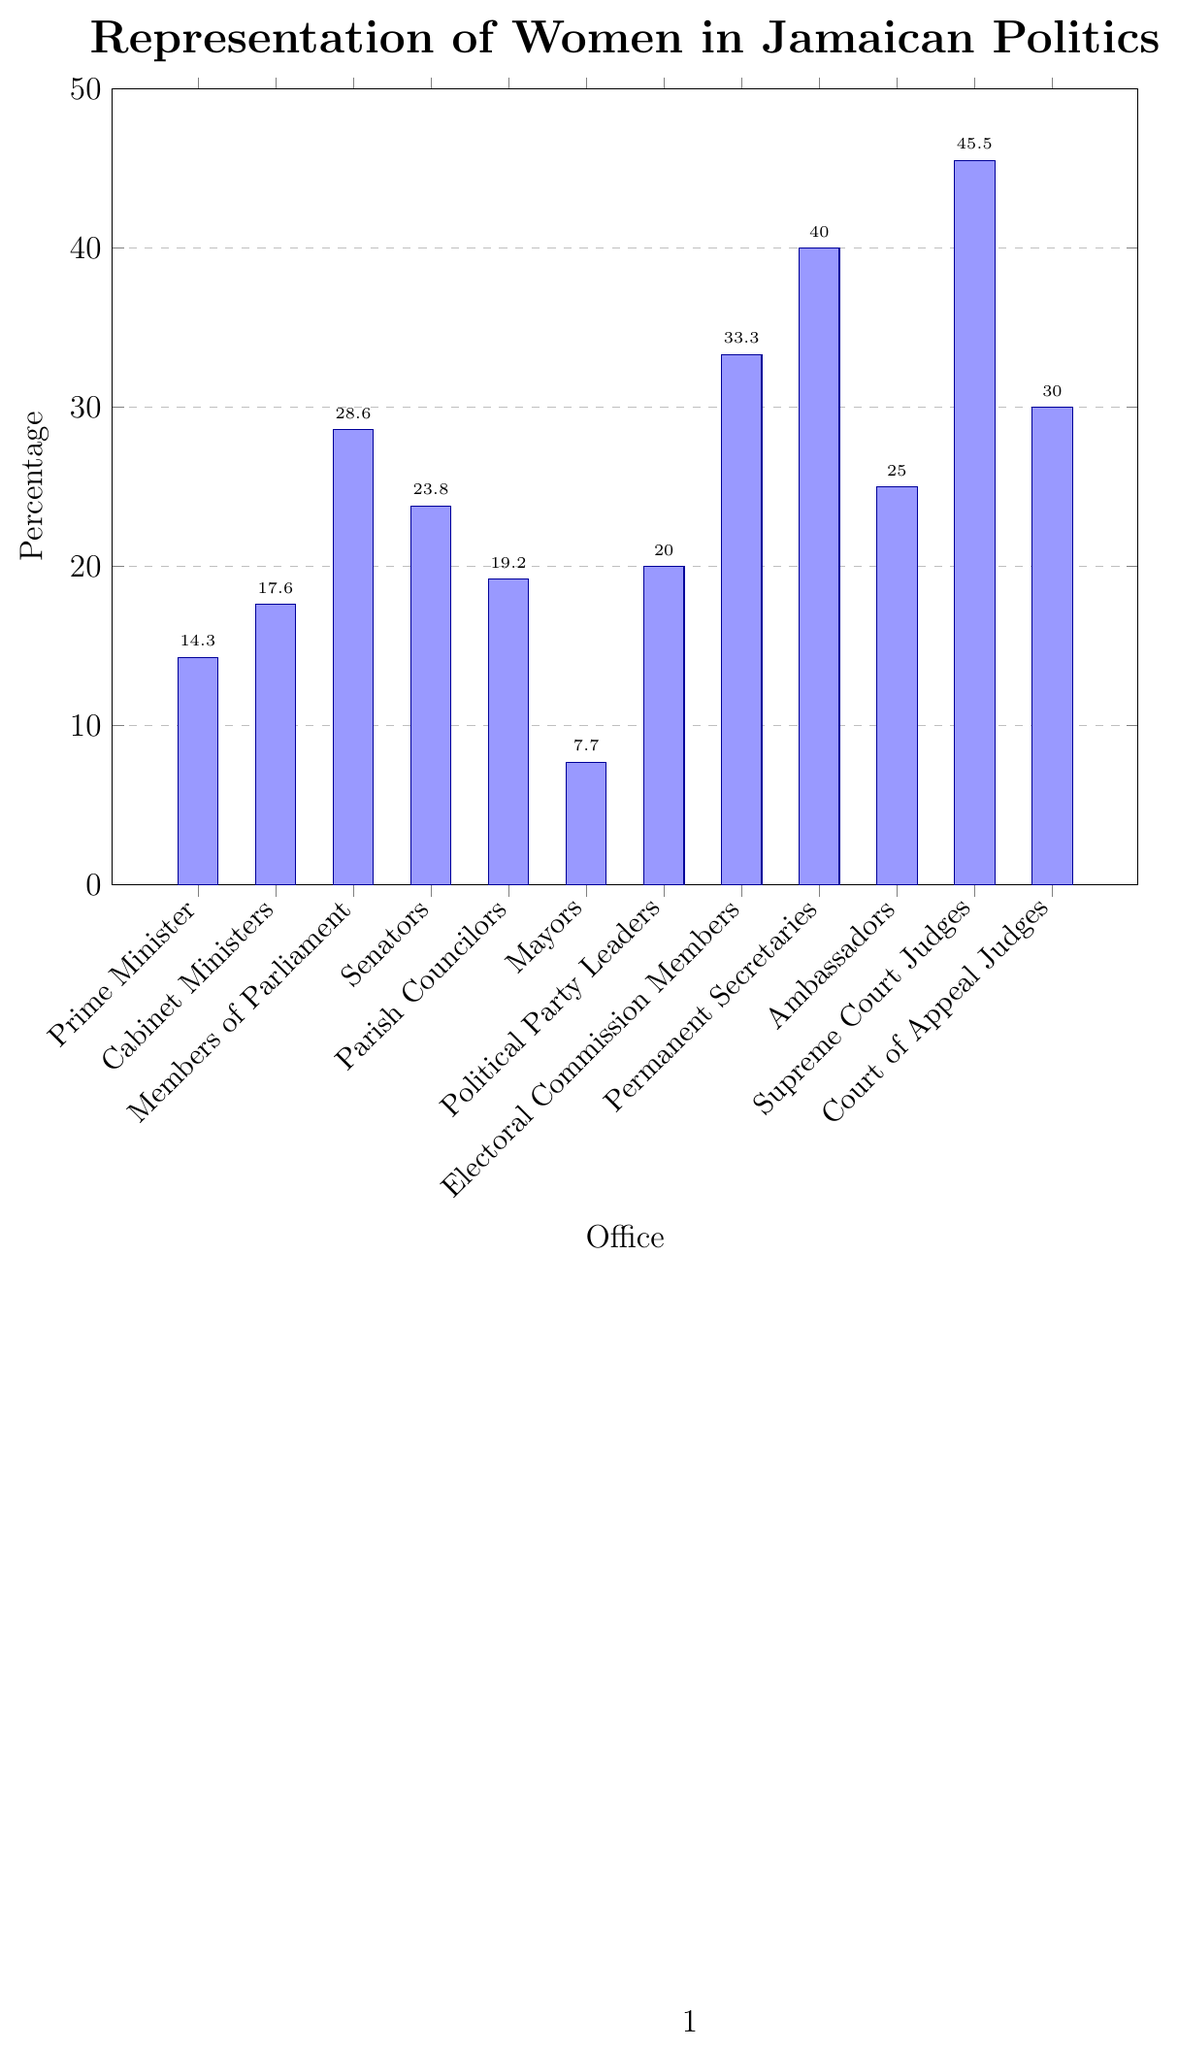What percentage of Supreme Court Judges are women? Look at the bar representing Supreme Court Judges, which is labeled on the x-axis and read the corresponding percentage on the y-axis.
Answer: 45.5 Which political office has the highest representation of women? Among all the bars, the tallest represents the office with the highest percentage.
Answer: Supreme Court Judges Which political office has the lowest representation of women? Identify the shortest bar among all, which indicates the office with the lowest percentage.
Answer: Mayors How does the percentage of women Cabinet Ministers compare to that of women Members of Parliament? Compare the heights of the bars labeled "Cabinet Ministers" and "Members of Parliament" to see which one is taller.
Answer: Members of Parliament have a higher percentage than Cabinet Ministers What is the combined percentage of women in the offices of Prime Minister, Cabinet Ministers, and Mayors? Add the percentages of Prime Minister (14.3), Cabinet Ministers (17.6), and Mayors (7.7).
Answer: 39.6 What is the average representation of women across all political offices shown in the chart? Sum the percentages of all the offices and divide by the number of offices (12). (14.3+17.6+28.6+23.8+19.2+7.7+20.0+33.3+40.0+25.0+45.5+30.0) / 12 = 24.2
Answer: 24.2 Which office has a higher percentage of women, Ambassadors or Senators? Compare the heights of the bars labeled "Ambassadors" and "Senators" to determine which is taller.
Answer: Senators have a higher percentage than Ambassadors What is the difference in percentage points between the representation of women among Political Party Leaders and Permanent Secretaries? Subtract the percentage of women Political Party Leaders from the percentage of women Permanent Secretaries (40.0 - 20.0).
Answer: 20.0 Which two offices have almost equal percentages of women representation? Identify bars of almost the same height, such as Political Party Leaders (20.0) and Parish Councilors (19.2).
Answer: Political Party Leaders and Parish Councilors How much greater is the percentage of women in the Court of Appeal Judges compared to Mayors? Subtract the percentage of women Mayors from the percentage of women Court of Appeal Judges (30.0 - 7.7).
Answer: 22.3 